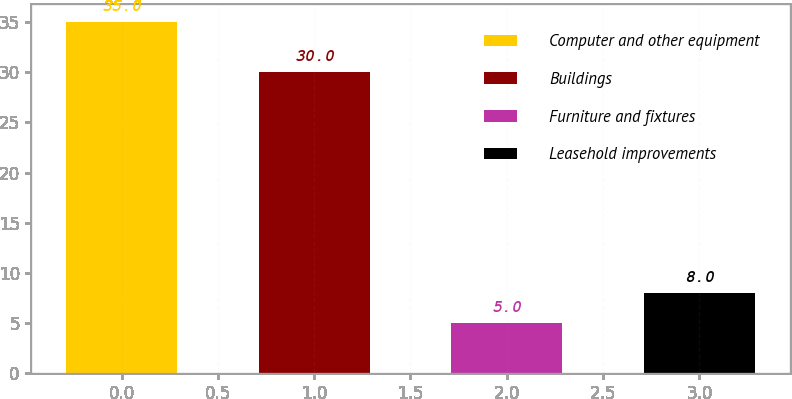<chart> <loc_0><loc_0><loc_500><loc_500><bar_chart><fcel>Computer and other equipment<fcel>Buildings<fcel>Furniture and fixtures<fcel>Leasehold improvements<nl><fcel>35<fcel>30<fcel>5<fcel>8<nl></chart> 